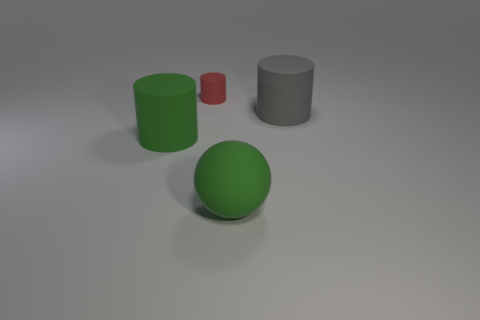Is the number of large rubber cylinders that are behind the gray rubber object less than the number of balls?
Give a very brief answer. Yes. Is there a big rubber cylinder that has the same color as the big matte ball?
Ensure brevity in your answer.  Yes. Do the large gray rubber thing and the tiny red object right of the green cylinder have the same shape?
Keep it short and to the point. Yes. Are there any other green cylinders that have the same material as the small cylinder?
Provide a short and direct response. Yes. There is a big matte cylinder that is behind the matte cylinder that is to the left of the small red matte cylinder; are there any large rubber things that are left of it?
Keep it short and to the point. Yes. How many other objects are there of the same shape as the red rubber object?
Provide a succinct answer. 2. There is a large matte cylinder that is to the left of the large rubber object that is behind the cylinder in front of the big gray cylinder; what is its color?
Offer a very short reply. Green. How many large cylinders are there?
Your answer should be compact. 2. What number of big objects are yellow metallic cylinders or green matte cylinders?
Your answer should be very brief. 1. There is a gray rubber thing that is the same size as the green rubber cylinder; what is its shape?
Make the answer very short. Cylinder. 